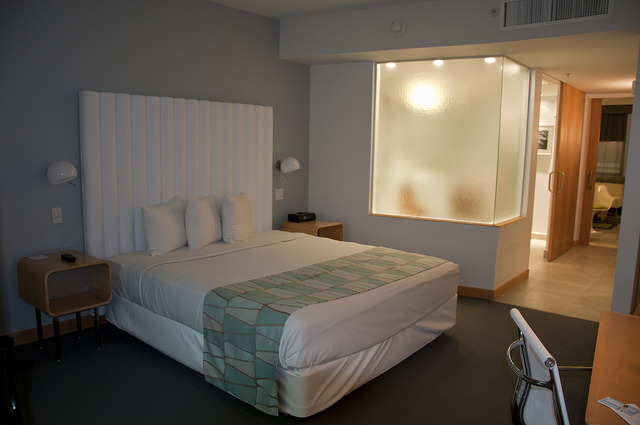Is this room suitable for people with accessibility needs? From what we can see in the image, the room seems spacious, possibly allowing for wheelchair maneuverability. However, we can't confirm if there are specific accommodations such as grab bars or roll-in showers without more information. 